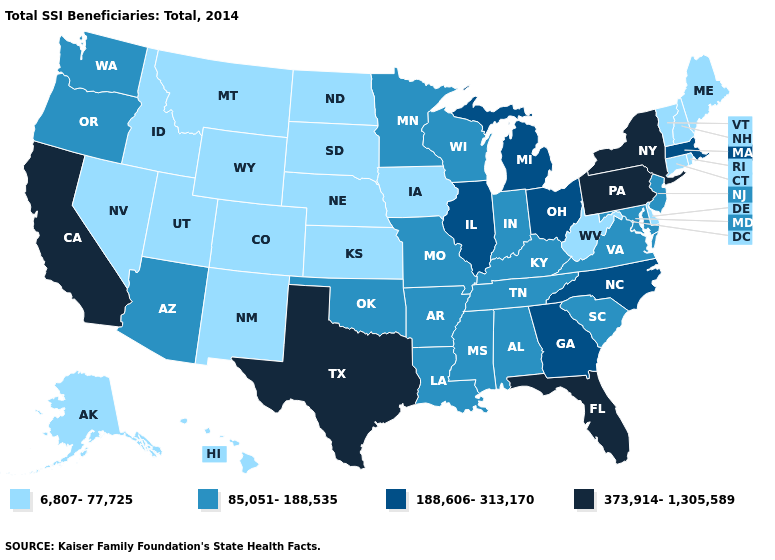Name the states that have a value in the range 85,051-188,535?
Quick response, please. Alabama, Arizona, Arkansas, Indiana, Kentucky, Louisiana, Maryland, Minnesota, Mississippi, Missouri, New Jersey, Oklahoma, Oregon, South Carolina, Tennessee, Virginia, Washington, Wisconsin. Does the map have missing data?
Short answer required. No. Among the states that border New Hampshire , does Vermont have the highest value?
Give a very brief answer. No. Name the states that have a value in the range 6,807-77,725?
Concise answer only. Alaska, Colorado, Connecticut, Delaware, Hawaii, Idaho, Iowa, Kansas, Maine, Montana, Nebraska, Nevada, New Hampshire, New Mexico, North Dakota, Rhode Island, South Dakota, Utah, Vermont, West Virginia, Wyoming. Which states have the lowest value in the USA?
Quick response, please. Alaska, Colorado, Connecticut, Delaware, Hawaii, Idaho, Iowa, Kansas, Maine, Montana, Nebraska, Nevada, New Hampshire, New Mexico, North Dakota, Rhode Island, South Dakota, Utah, Vermont, West Virginia, Wyoming. Does South Dakota have a lower value than Illinois?
Keep it brief. Yes. Does the map have missing data?
Quick response, please. No. What is the lowest value in the USA?
Be succinct. 6,807-77,725. How many symbols are there in the legend?
Keep it brief. 4. Among the states that border California , which have the lowest value?
Write a very short answer. Nevada. What is the highest value in the USA?
Give a very brief answer. 373,914-1,305,589. What is the highest value in states that border Maine?
Give a very brief answer. 6,807-77,725. Name the states that have a value in the range 188,606-313,170?
Quick response, please. Georgia, Illinois, Massachusetts, Michigan, North Carolina, Ohio. Name the states that have a value in the range 373,914-1,305,589?
Short answer required. California, Florida, New York, Pennsylvania, Texas. 